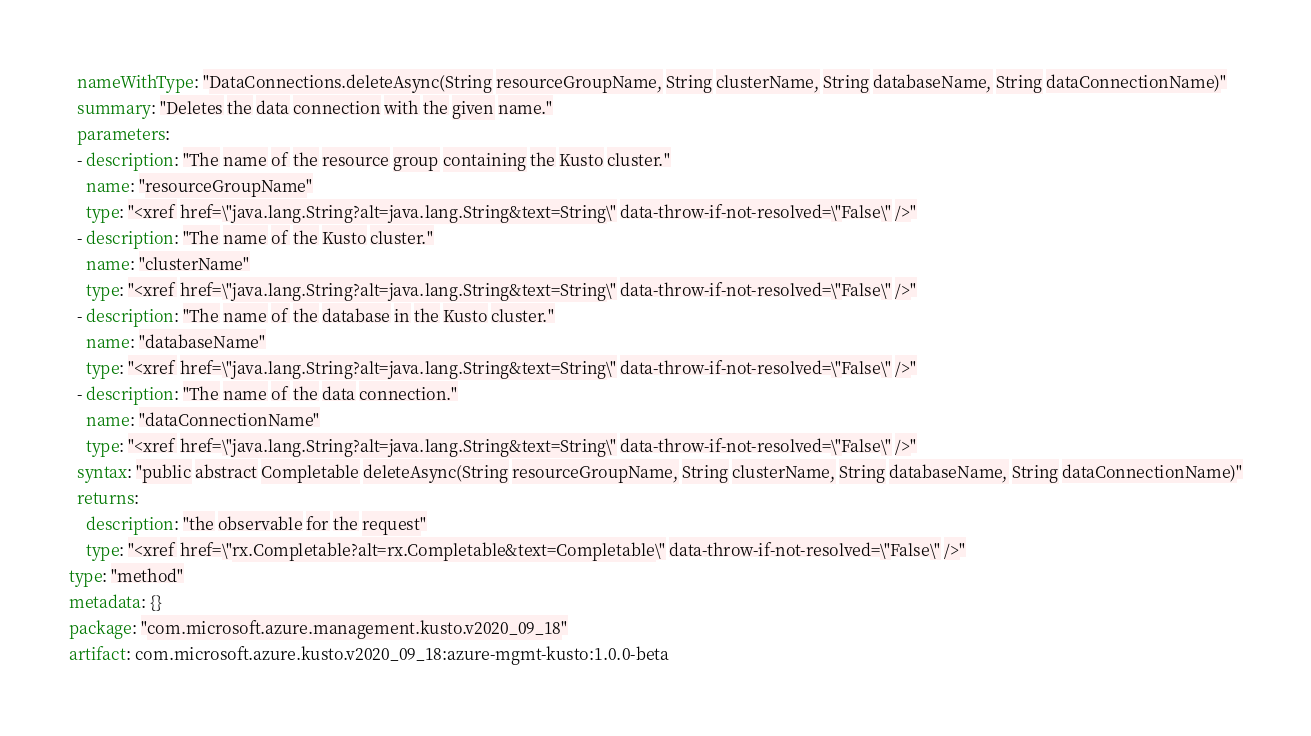Convert code to text. <code><loc_0><loc_0><loc_500><loc_500><_YAML_>  nameWithType: "DataConnections.deleteAsync(String resourceGroupName, String clusterName, String databaseName, String dataConnectionName)"
  summary: "Deletes the data connection with the given name."
  parameters:
  - description: "The name of the resource group containing the Kusto cluster."
    name: "resourceGroupName"
    type: "<xref href=\"java.lang.String?alt=java.lang.String&text=String\" data-throw-if-not-resolved=\"False\" />"
  - description: "The name of the Kusto cluster."
    name: "clusterName"
    type: "<xref href=\"java.lang.String?alt=java.lang.String&text=String\" data-throw-if-not-resolved=\"False\" />"
  - description: "The name of the database in the Kusto cluster."
    name: "databaseName"
    type: "<xref href=\"java.lang.String?alt=java.lang.String&text=String\" data-throw-if-not-resolved=\"False\" />"
  - description: "The name of the data connection."
    name: "dataConnectionName"
    type: "<xref href=\"java.lang.String?alt=java.lang.String&text=String\" data-throw-if-not-resolved=\"False\" />"
  syntax: "public abstract Completable deleteAsync(String resourceGroupName, String clusterName, String databaseName, String dataConnectionName)"
  returns:
    description: "the observable for the request"
    type: "<xref href=\"rx.Completable?alt=rx.Completable&text=Completable\" data-throw-if-not-resolved=\"False\" />"
type: "method"
metadata: {}
package: "com.microsoft.azure.management.kusto.v2020_09_18"
artifact: com.microsoft.azure.kusto.v2020_09_18:azure-mgmt-kusto:1.0.0-beta
</code> 